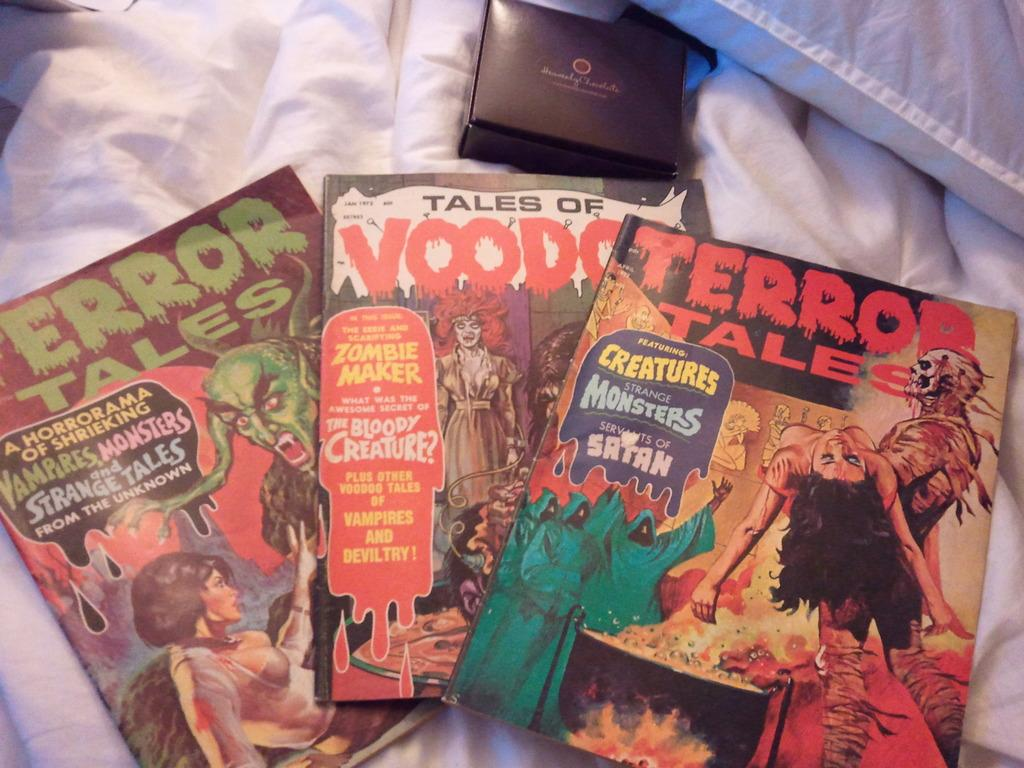<image>
Present a compact description of the photo's key features. A bunch of horror comics including Terror Tales and Tales of Voodoo. 